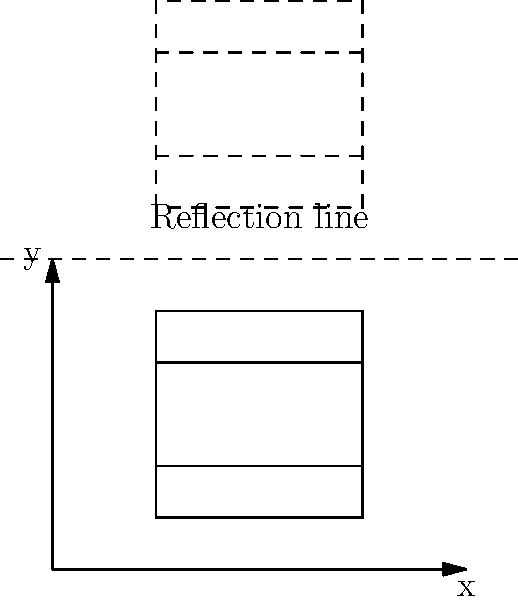In your latest novel, you describe a grand library with perfect symmetry. The diagram shows a bookshelf and its reflection across a horizontal line. If the original bookshelf has coordinates $A(1,0.5)$, $B(1,2.5)$, $C(3,2.5)$, and $D(3,0.5)$, what are the coordinates of point $B'$ (the reflection of point $B$) after the transformation? To find the coordinates of point $B'$, we need to reflect point $B(1,2.5)$ across the horizontal line $y=3$. The steps are as follows:

1) In a reflection across a horizontal line $y=k$, the x-coordinate remains the same, while the y-coordinate changes.

2) The formula for the y-coordinate of the reflected point is:
   $y' = 2k - y$, where $k$ is the y-coordinate of the reflection line.

3) In this case, $k=3$ (the y-coordinate of the reflection line), and the original point $B$ has coordinates $(1,2.5)$.

4) Let's apply the formula:
   $x' = 1$ (remains the same)
   $y' = 2(3) - 2.5 = 6 - 2.5 = 3.5$

5) Therefore, the coordinates of $B'$ are $(1,3.5)$.

This reflection creates a symmetrical layout for the library, mirroring the structure of language and narrative in your novels.
Answer: $(1,3.5)$ 